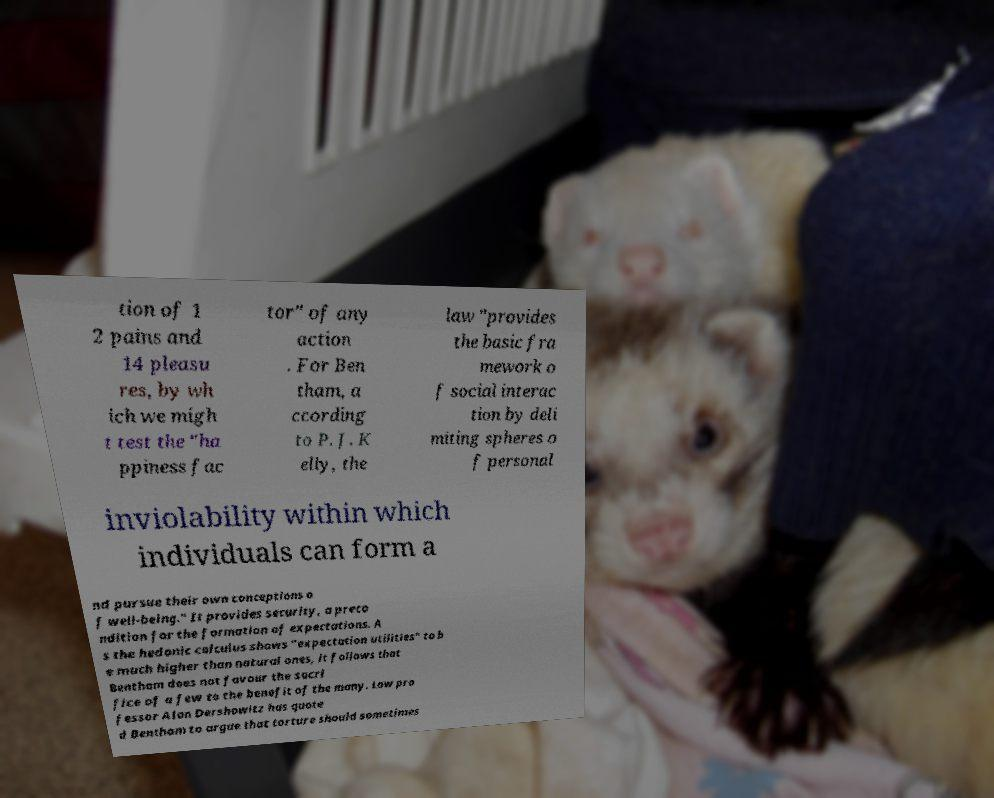Please read and relay the text visible in this image. What does it say? tion of 1 2 pains and 14 pleasu res, by wh ich we migh t test the "ha ppiness fac tor" of any action . For Ben tham, a ccording to P. J. K elly, the law "provides the basic fra mework o f social interac tion by deli miting spheres o f personal inviolability within which individuals can form a nd pursue their own conceptions o f well-being." It provides security, a preco ndition for the formation of expectations. A s the hedonic calculus shows "expectation utilities" to b e much higher than natural ones, it follows that Bentham does not favour the sacri fice of a few to the benefit of the many. Law pro fessor Alan Dershowitz has quote d Bentham to argue that torture should sometimes 